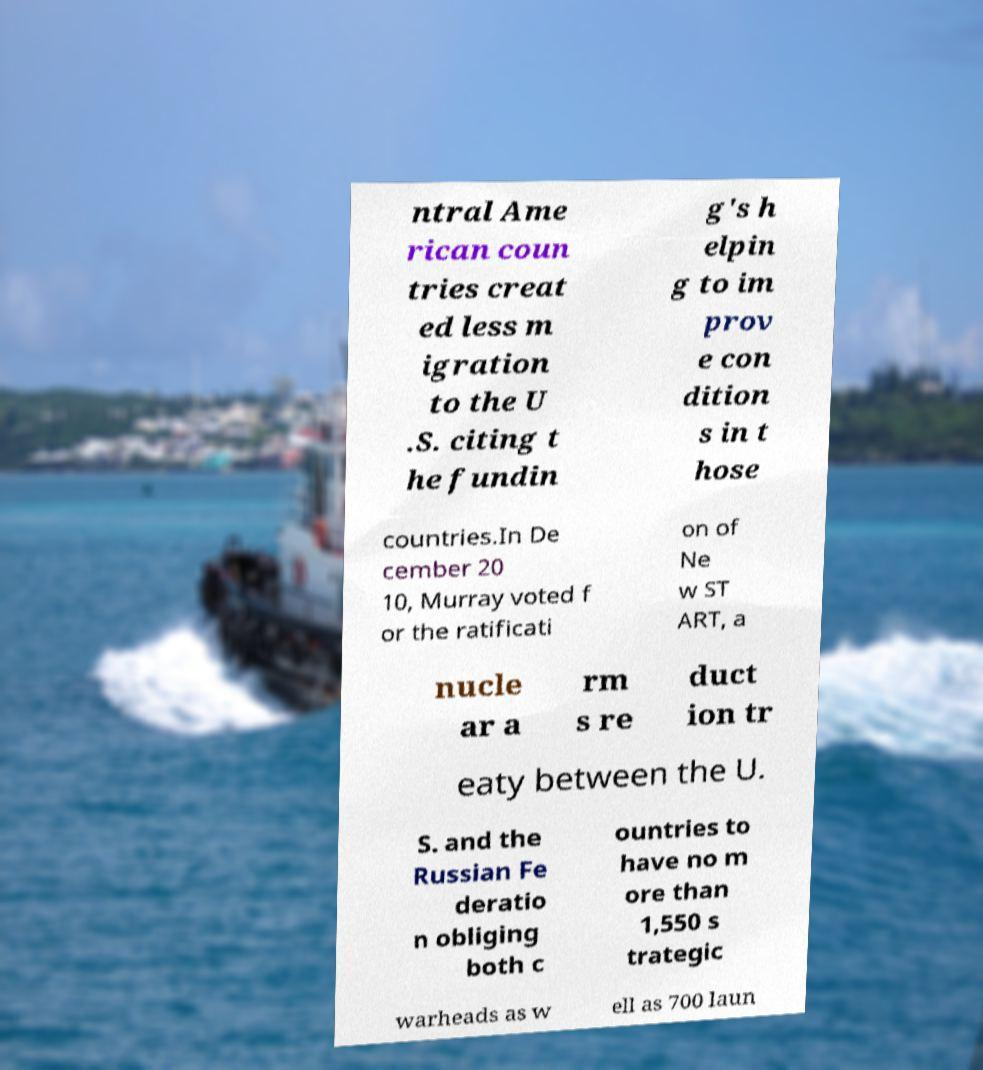Can you accurately transcribe the text from the provided image for me? ntral Ame rican coun tries creat ed less m igration to the U .S. citing t he fundin g's h elpin g to im prov e con dition s in t hose countries.In De cember 20 10, Murray voted f or the ratificati on of Ne w ST ART, a nucle ar a rm s re duct ion tr eaty between the U. S. and the Russian Fe deratio n obliging both c ountries to have no m ore than 1,550 s trategic warheads as w ell as 700 laun 